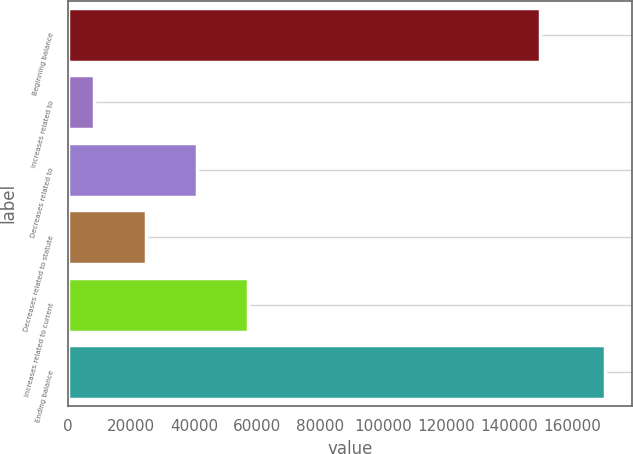<chart> <loc_0><loc_0><loc_500><loc_500><bar_chart><fcel>Beginning balance<fcel>Increases related to<fcel>Decreases related to<fcel>Decreases related to statute<fcel>Increases related to current<fcel>Ending balance<nl><fcel>149878<fcel>8381<fcel>40835.6<fcel>24608.3<fcel>57062.9<fcel>170654<nl></chart> 